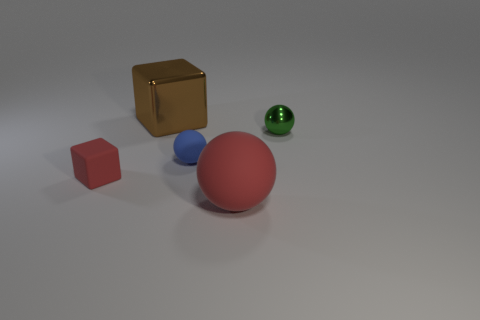Subtract all red matte balls. How many balls are left? 2 Add 3 tiny blue rubber spheres. How many objects exist? 8 Subtract all balls. How many objects are left? 2 Subtract all cyan balls. Subtract all green cubes. How many balls are left? 3 Subtract all tiny cyan objects. Subtract all red rubber objects. How many objects are left? 3 Add 3 large metal cubes. How many large metal cubes are left? 4 Add 3 brown shiny cylinders. How many brown shiny cylinders exist? 3 Subtract 1 brown cubes. How many objects are left? 4 